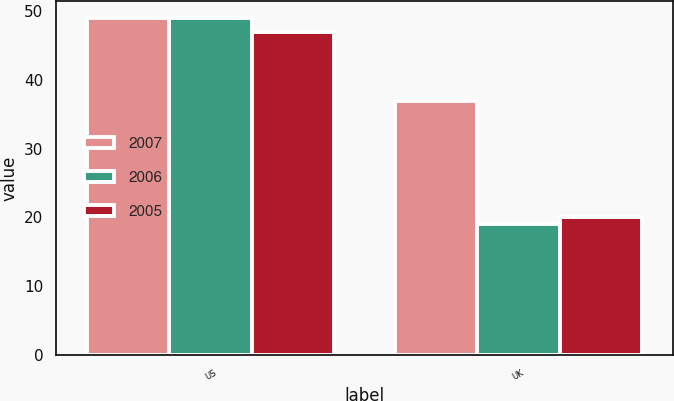Convert chart. <chart><loc_0><loc_0><loc_500><loc_500><stacked_bar_chart><ecel><fcel>US<fcel>UK<nl><fcel>2007<fcel>49<fcel>37<nl><fcel>2006<fcel>49<fcel>19<nl><fcel>2005<fcel>47<fcel>20<nl></chart> 